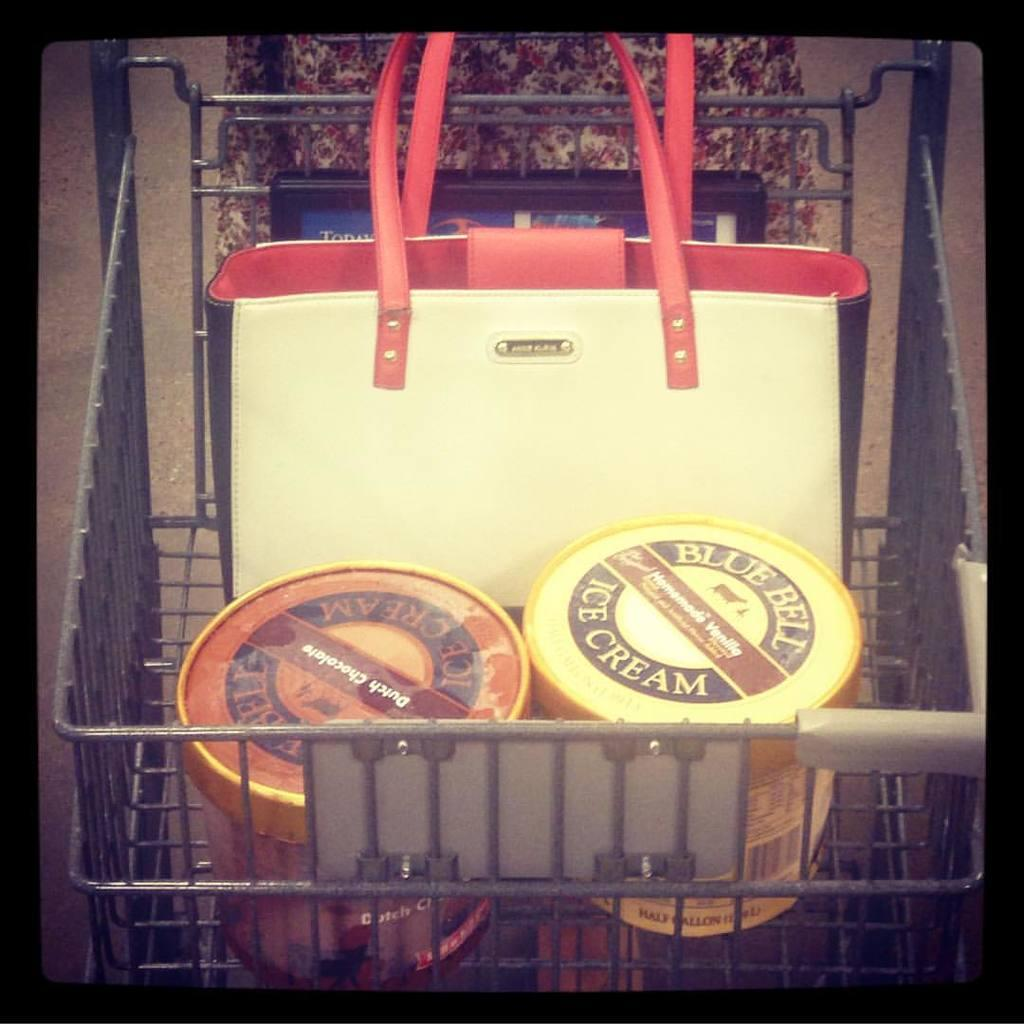What is present in the image that can be used for carrying items? There is a bag in the image that can be used for carrying items. What else can be seen in the image that can be used for carrying items? There are bottles in the image that can be used for carrying items. Where are the bag and bottles located in the image? The bag and bottles are in a trolley. What type of badge is being worn by the horse pulling the carriage in the image? There is no horse or carriage present in the image; it only features a bag, bottles, and a trolley. 